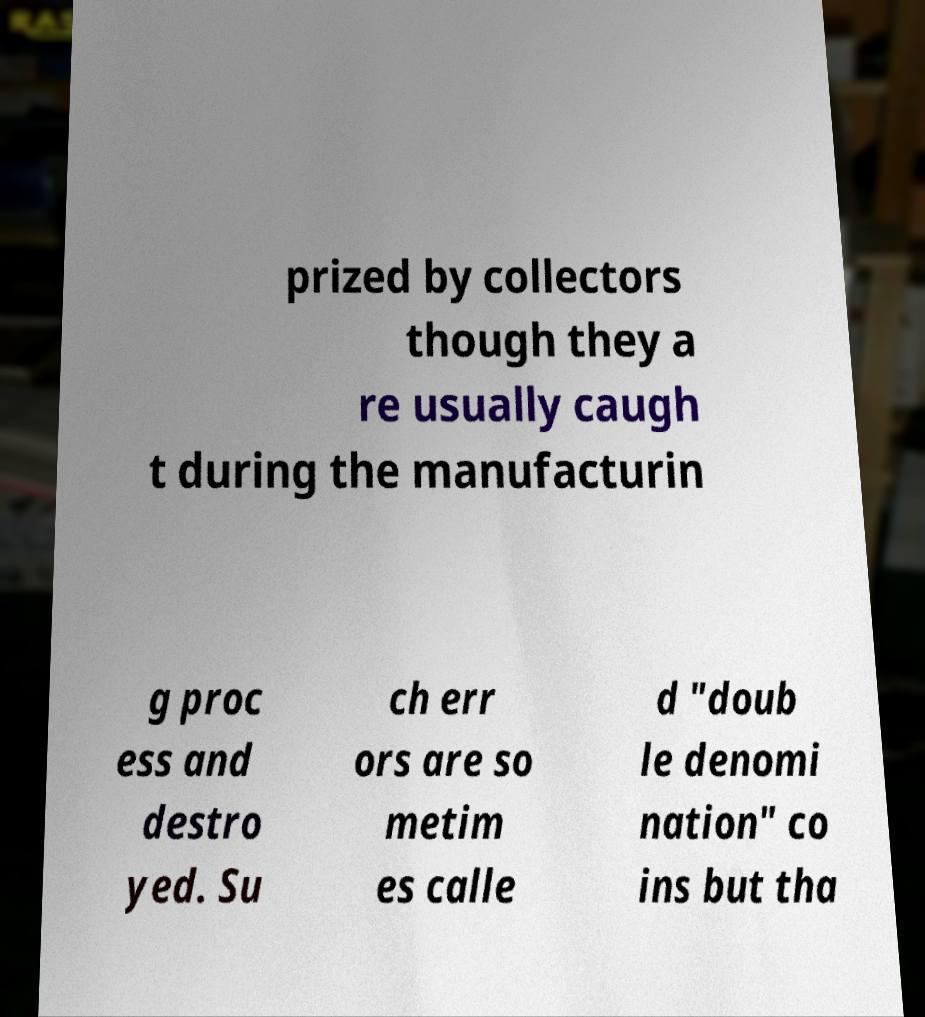Can you accurately transcribe the text from the provided image for me? prized by collectors though they a re usually caugh t during the manufacturin g proc ess and destro yed. Su ch err ors are so metim es calle d "doub le denomi nation" co ins but tha 